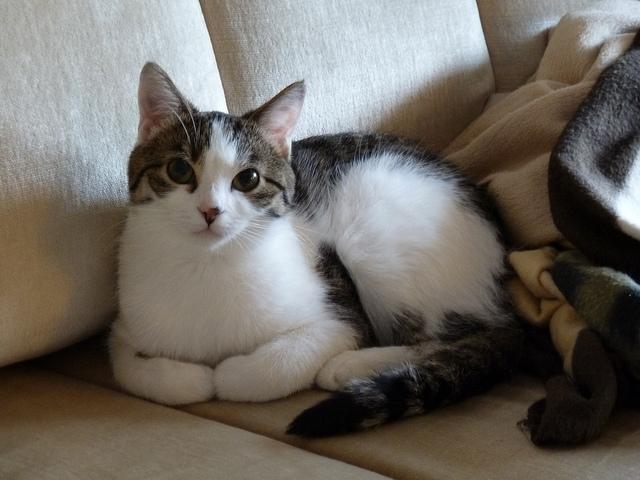Is the pattern on the couch strips?
Keep it brief. No. What is the cat sitting on?
Give a very brief answer. Couch. What color are the cat's eyes?
Quick response, please. Brown. What color is the cat?
Keep it brief. White. 